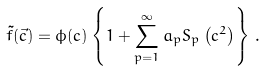<formula> <loc_0><loc_0><loc_500><loc_500>\tilde { f } ( \vec { c } ) = \phi ( c ) \left \{ 1 + \sum _ { p = 1 } ^ { \infty } a _ { p } S _ { p } \left ( c ^ { 2 } \right ) \right \} \, .</formula> 